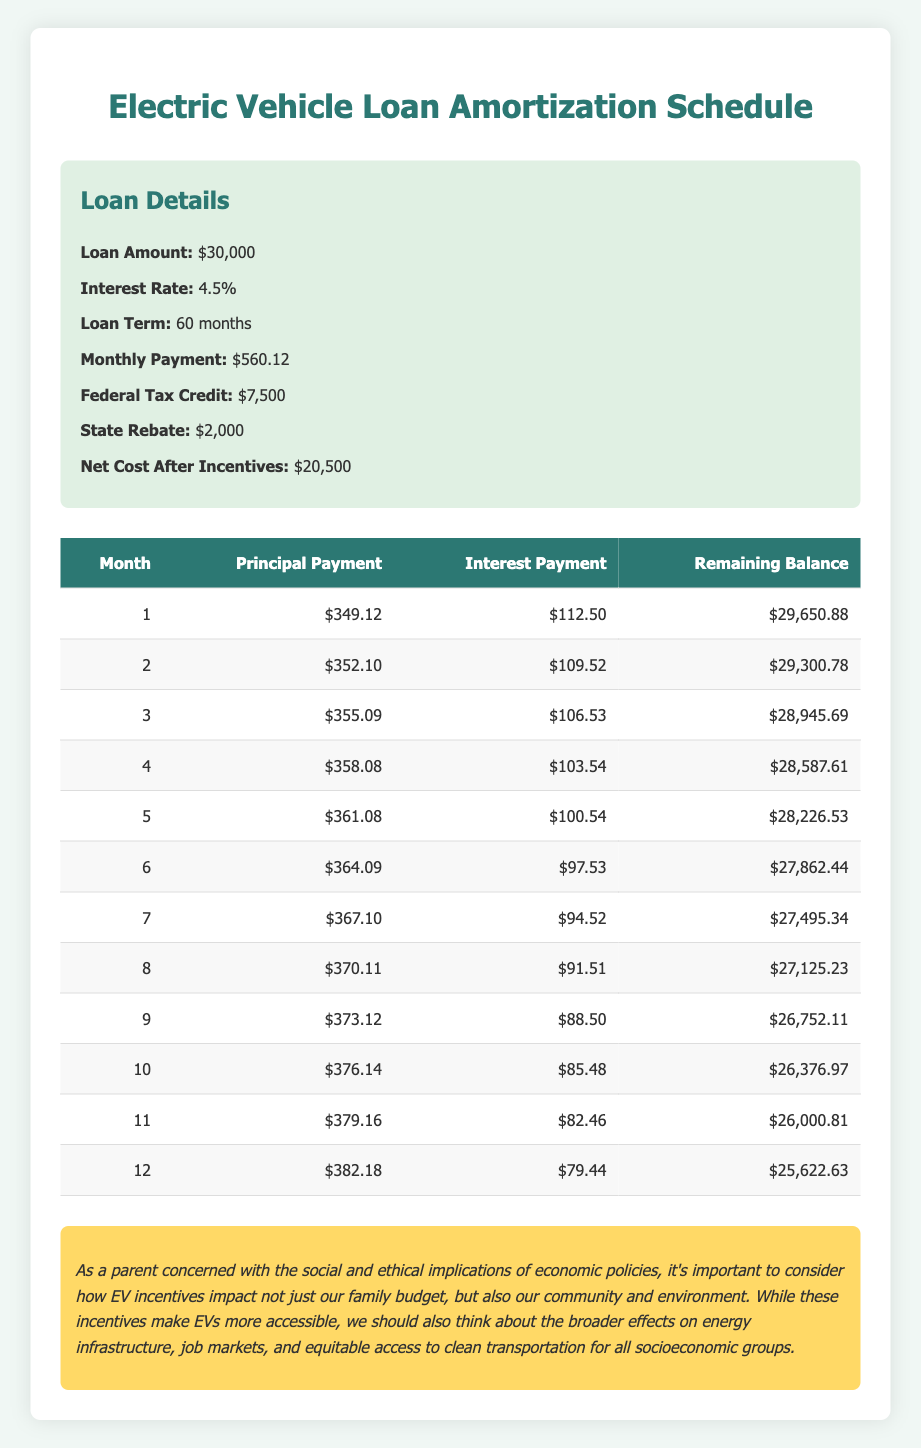What is the monthly principal payment for the first month? In the amortization schedule, the principal payment for the first month is explicitly listed in the first row under the "Principal Payment" column. The value is 349.12.
Answer: 349.12 What is the remaining balance after the second month? In the amortization schedule, the remaining balance after the second month is explicitly listed in the second row under the "Remaining Balance" column. The value is 29300.78.
Answer: 29300.78 What is the total principal payment made in the first three months? To find the total principal payment for the first three months, we add the principal payments from the first three months: 349.12 + 352.10 + 355.09 = 1056.31.
Answer: 1056.31 Is the interest payment for the sixth month higher than the interest payment for the fifth month? By comparing the interest payments from the amortization schedule, the interest payment for the sixth month is 97.53 and the interest payment for the fifth month is 100.54. Since 97.53 is less than 100.54, the statement is false.
Answer: No What is the average principal payment over the first twelve months? To calculate the average principal payment for the first twelve months, we sum the principal payments for all twelve months and then divide by 12. The total principal payments add up to 4,033.21 (found by summing individual principal payments), so the average is 4,033.21 / 12 = 336.10.
Answer: 336.10 What is the difference in remaining balance between the first month and the fourth month? The remaining balance for the first month is 29650.88, and for the fourth month, it is 28587.61. The difference is calculated by subtracting the fourth month's balance from the first month's: 29650.88 - 28587.61 = 1063.27.
Answer: 1063.27 By the end of the first year (12 months), how much total interest has been paid? To find the total interest paid by the end of the first year, sum the interest payments for each of the twelve months: 112.50 + 109.52 + 106.53 + ... + 79.44, which equals 1,167.21.
Answer: 1167.21 Is the federal tax credit more than the combined total of the monthly payments for the first year? The total monthly payment for twelve months is calculated as 560.12 * 12 = 6,721.44. The federal tax credit is 7,500, which is greater than 6,721.44. Therefore, the statement is true.
Answer: Yes 